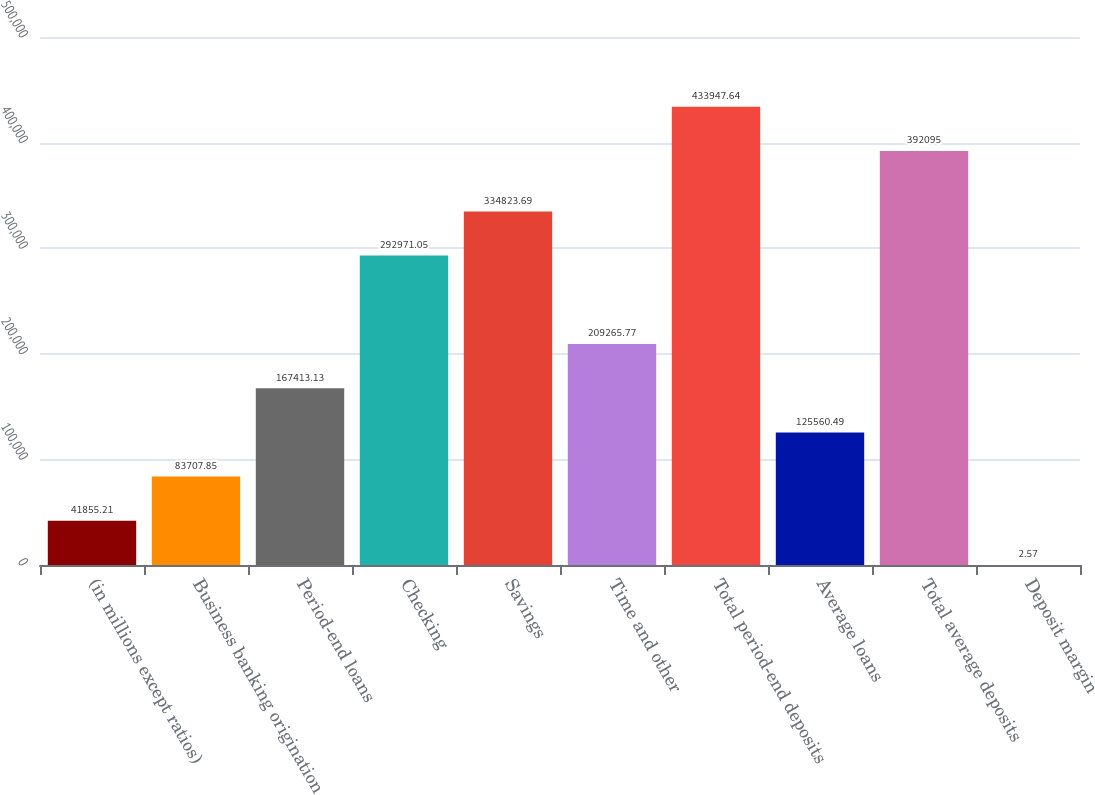Convert chart. <chart><loc_0><loc_0><loc_500><loc_500><bar_chart><fcel>(in millions except ratios)<fcel>Business banking origination<fcel>Period-end loans<fcel>Checking<fcel>Savings<fcel>Time and other<fcel>Total period-end deposits<fcel>Average loans<fcel>Total average deposits<fcel>Deposit margin<nl><fcel>41855.2<fcel>83707.9<fcel>167413<fcel>292971<fcel>334824<fcel>209266<fcel>433948<fcel>125560<fcel>392095<fcel>2.57<nl></chart> 